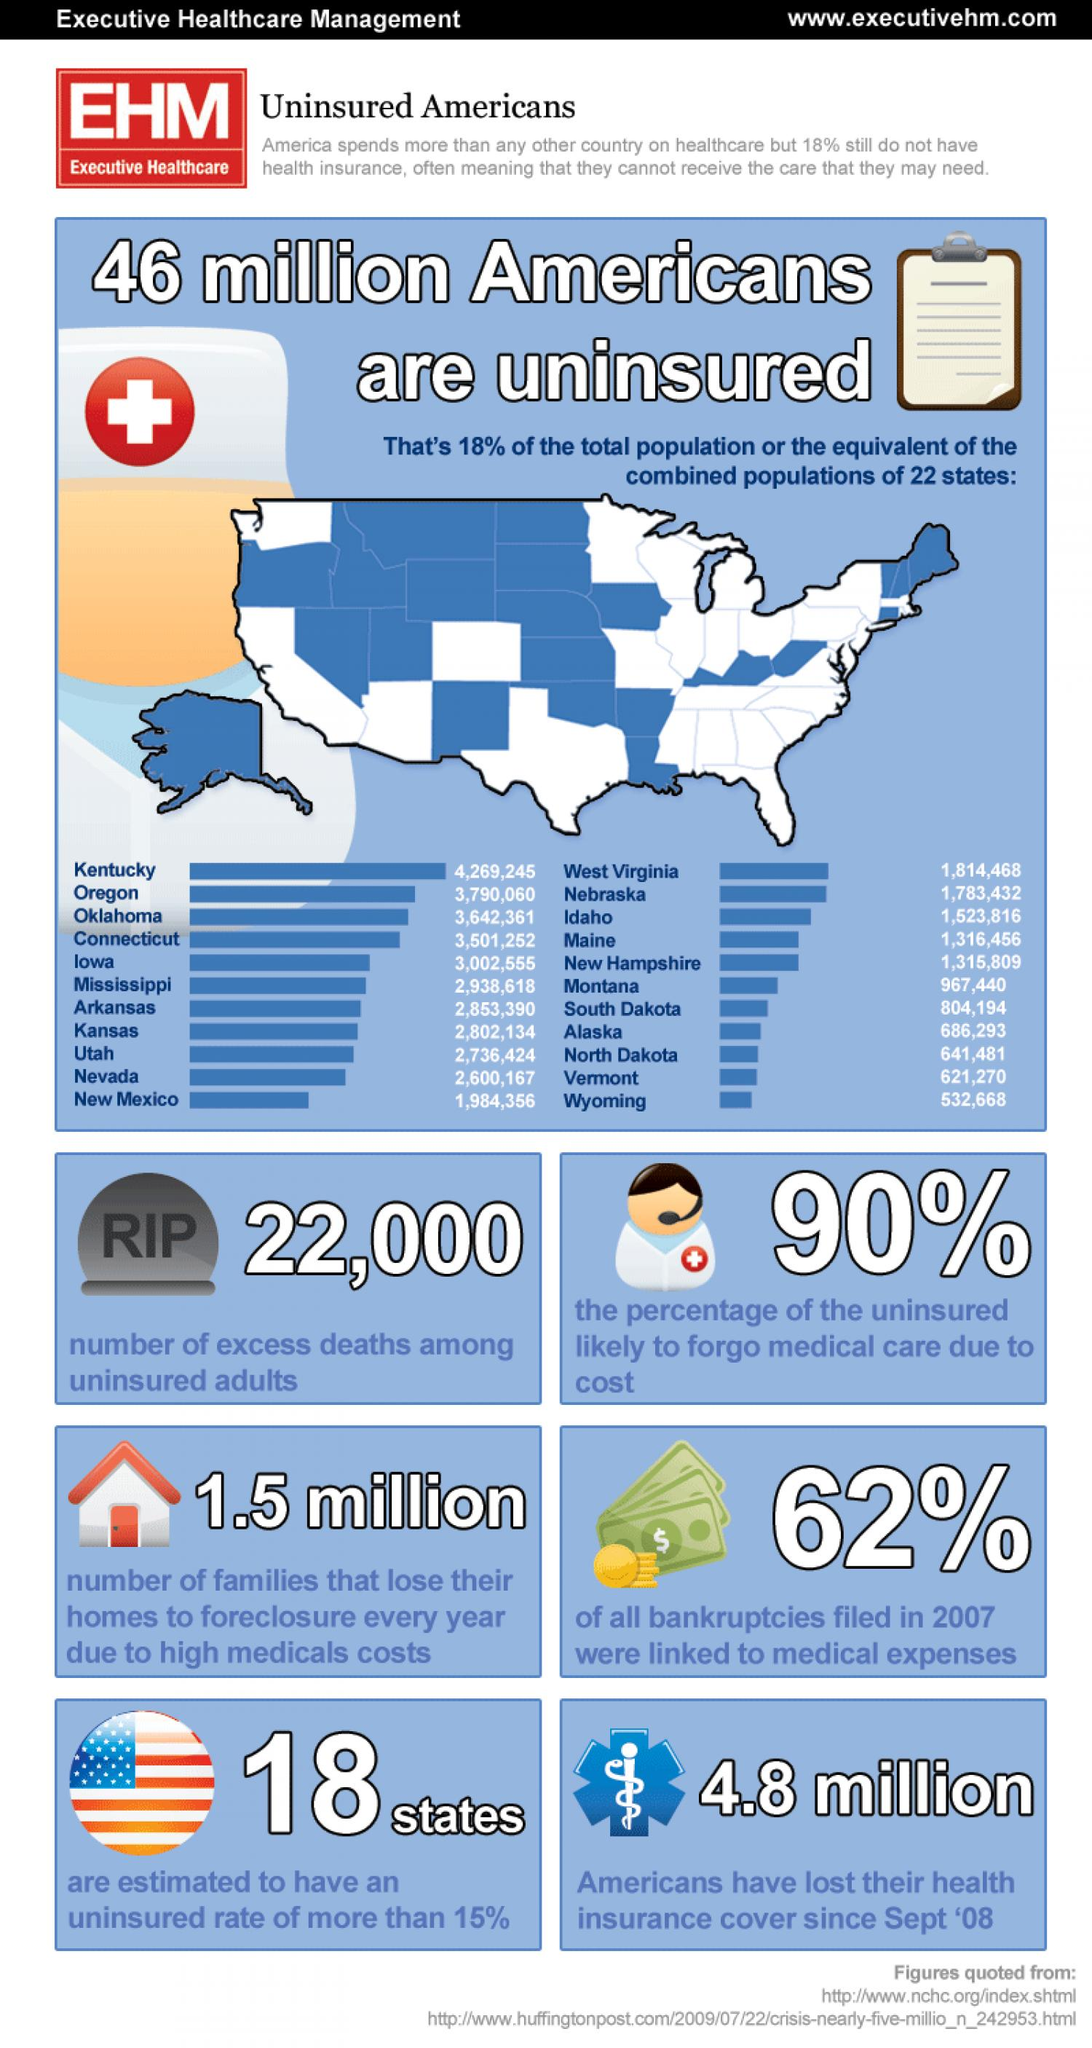Indicate a few pertinent items in this graphic. It is unlikely that 10% of the population will forgo medical care due to cost, despite the high cost of healthcare. Wyoming and Vermont have a combined population of 1,153,938 people as of 2021. Eighteen states have an insured rate of less than 85%. 